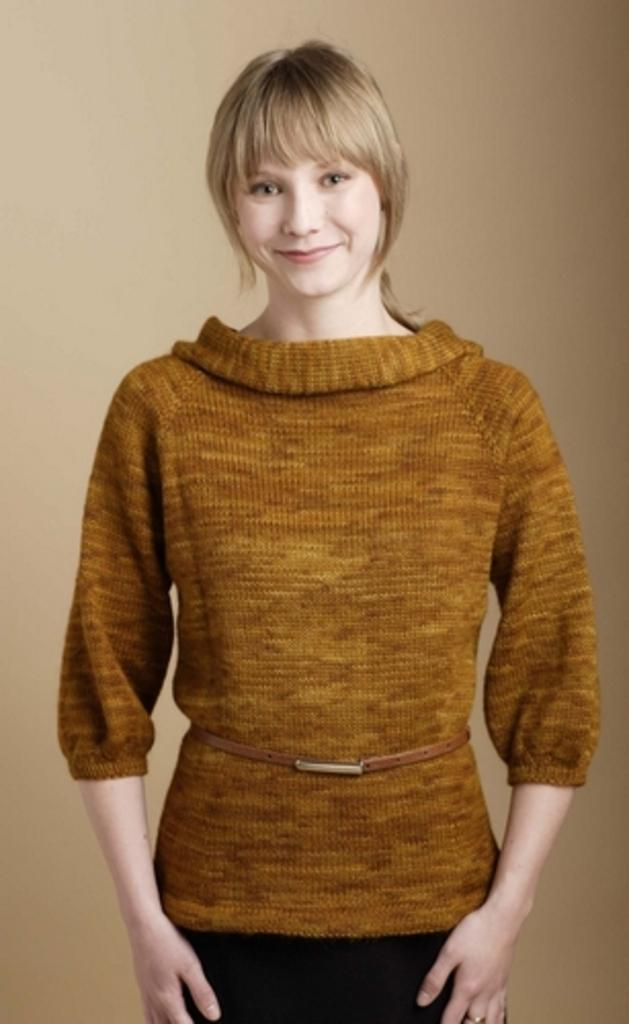What is the primary subject of the image? There is a woman in the image. What is the woman doing in the image? The woman is standing and smiling. What can be observed about the background in the image? The background in the image is solid. What type of writing can be seen on the woman's arm in the image? There is no writing visible on the woman's arm in the image. What color is the flesh of the woman's hand in the image? The color of the woman's flesh cannot be determined from the image, as it is in black and white. 